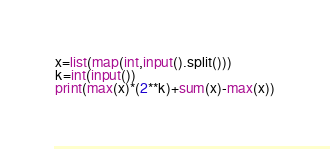<code> <loc_0><loc_0><loc_500><loc_500><_Python_>x=list(map(int,input().split()))
k=int(input())
print(max(x)*(2**k)+sum(x)-max(x))</code> 